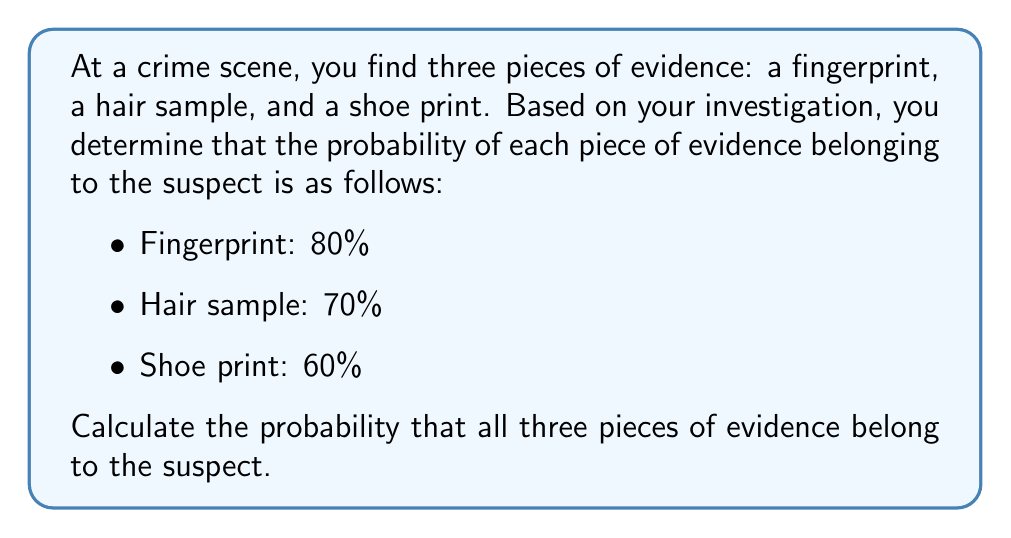Solve this math problem. To solve this problem, we need to use the multiplication rule of probability for independent events. Since we want the probability of all three pieces of evidence belonging to the suspect, we need to multiply the individual probabilities:

1. Convert percentages to decimal form:
   Fingerprint: 80% = 0.80
   Hair sample: 70% = 0.70
   Shoe print: 60% = 0.60

2. Apply the multiplication rule:
   $$P(\text{All evidence belongs to suspect}) = P(\text{Fingerprint}) \times P(\text{Hair}) \times P(\text{Shoe print})$$

3. Substitute the values:
   $$P(\text{All evidence belongs to suspect}) = 0.80 \times 0.70 \times 0.60$$

4. Perform the multiplication:
   $$P(\text{All evidence belongs to suspect}) = 0.336$$

5. Convert the result to a percentage:
   $$0.336 \times 100\% = 33.6\%$$

Therefore, the probability that all three pieces of evidence belong to the suspect is 33.6%.
Answer: 33.6% 